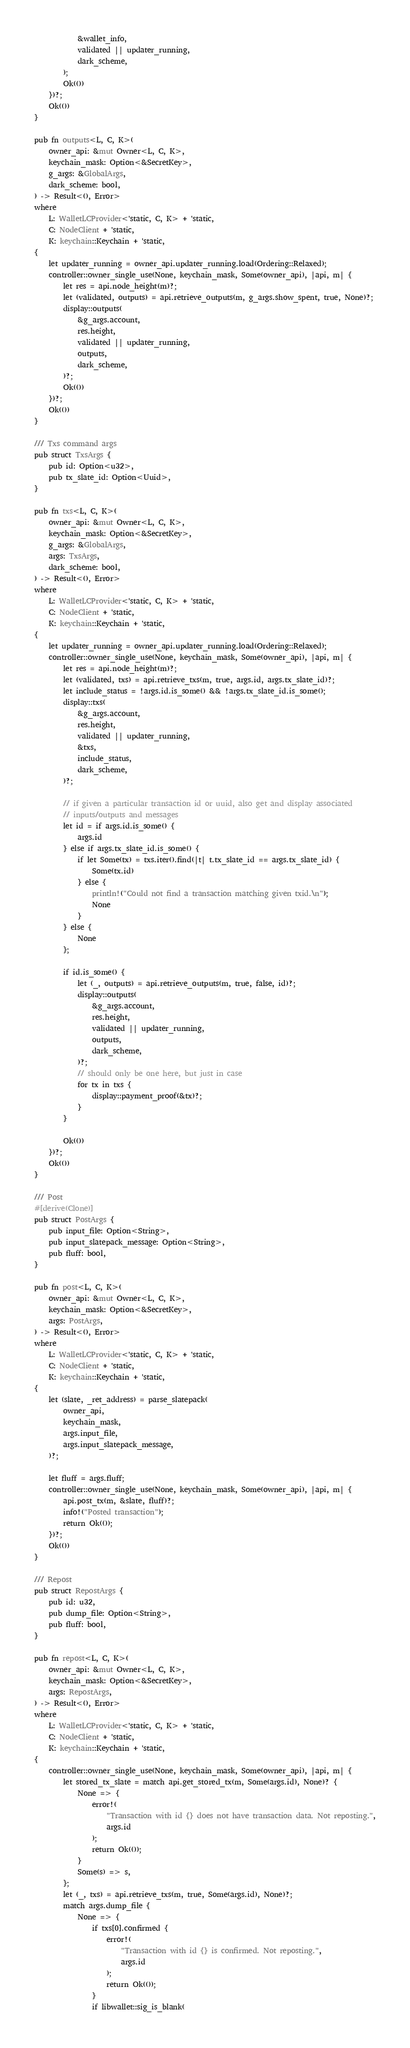Convert code to text. <code><loc_0><loc_0><loc_500><loc_500><_Rust_>			&wallet_info,
			validated || updater_running,
			dark_scheme,
		);
		Ok(())
	})?;
	Ok(())
}

pub fn outputs<L, C, K>(
	owner_api: &mut Owner<L, C, K>,
	keychain_mask: Option<&SecretKey>,
	g_args: &GlobalArgs,
	dark_scheme: bool,
) -> Result<(), Error>
where
	L: WalletLCProvider<'static, C, K> + 'static,
	C: NodeClient + 'static,
	K: keychain::Keychain + 'static,
{
	let updater_running = owner_api.updater_running.load(Ordering::Relaxed);
	controller::owner_single_use(None, keychain_mask, Some(owner_api), |api, m| {
		let res = api.node_height(m)?;
		let (validated, outputs) = api.retrieve_outputs(m, g_args.show_spent, true, None)?;
		display::outputs(
			&g_args.account,
			res.height,
			validated || updater_running,
			outputs,
			dark_scheme,
		)?;
		Ok(())
	})?;
	Ok(())
}

/// Txs command args
pub struct TxsArgs {
	pub id: Option<u32>,
	pub tx_slate_id: Option<Uuid>,
}

pub fn txs<L, C, K>(
	owner_api: &mut Owner<L, C, K>,
	keychain_mask: Option<&SecretKey>,
	g_args: &GlobalArgs,
	args: TxsArgs,
	dark_scheme: bool,
) -> Result<(), Error>
where
	L: WalletLCProvider<'static, C, K> + 'static,
	C: NodeClient + 'static,
	K: keychain::Keychain + 'static,
{
	let updater_running = owner_api.updater_running.load(Ordering::Relaxed);
	controller::owner_single_use(None, keychain_mask, Some(owner_api), |api, m| {
		let res = api.node_height(m)?;
		let (validated, txs) = api.retrieve_txs(m, true, args.id, args.tx_slate_id)?;
		let include_status = !args.id.is_some() && !args.tx_slate_id.is_some();
		display::txs(
			&g_args.account,
			res.height,
			validated || updater_running,
			&txs,
			include_status,
			dark_scheme,
		)?;

		// if given a particular transaction id or uuid, also get and display associated
		// inputs/outputs and messages
		let id = if args.id.is_some() {
			args.id
		} else if args.tx_slate_id.is_some() {
			if let Some(tx) = txs.iter().find(|t| t.tx_slate_id == args.tx_slate_id) {
				Some(tx.id)
			} else {
				println!("Could not find a transaction matching given txid.\n");
				None
			}
		} else {
			None
		};

		if id.is_some() {
			let (_, outputs) = api.retrieve_outputs(m, true, false, id)?;
			display::outputs(
				&g_args.account,
				res.height,
				validated || updater_running,
				outputs,
				dark_scheme,
			)?;
			// should only be one here, but just in case
			for tx in txs {
				display::payment_proof(&tx)?;
			}
		}

		Ok(())
	})?;
	Ok(())
}

/// Post
#[derive(Clone)]
pub struct PostArgs {
	pub input_file: Option<String>,
	pub input_slatepack_message: Option<String>,
	pub fluff: bool,
}

pub fn post<L, C, K>(
	owner_api: &mut Owner<L, C, K>,
	keychain_mask: Option<&SecretKey>,
	args: PostArgs,
) -> Result<(), Error>
where
	L: WalletLCProvider<'static, C, K> + 'static,
	C: NodeClient + 'static,
	K: keychain::Keychain + 'static,
{
	let (slate, _ret_address) = parse_slatepack(
		owner_api,
		keychain_mask,
		args.input_file,
		args.input_slatepack_message,
	)?;

	let fluff = args.fluff;
	controller::owner_single_use(None, keychain_mask, Some(owner_api), |api, m| {
		api.post_tx(m, &slate, fluff)?;
		info!("Posted transaction");
		return Ok(());
	})?;
	Ok(())
}

/// Repost
pub struct RepostArgs {
	pub id: u32,
	pub dump_file: Option<String>,
	pub fluff: bool,
}

pub fn repost<L, C, K>(
	owner_api: &mut Owner<L, C, K>,
	keychain_mask: Option<&SecretKey>,
	args: RepostArgs,
) -> Result<(), Error>
where
	L: WalletLCProvider<'static, C, K> + 'static,
	C: NodeClient + 'static,
	K: keychain::Keychain + 'static,
{
	controller::owner_single_use(None, keychain_mask, Some(owner_api), |api, m| {
		let stored_tx_slate = match api.get_stored_tx(m, Some(args.id), None)? {
			None => {
				error!(
					"Transaction with id {} does not have transaction data. Not reposting.",
					args.id
				);
				return Ok(());
			}
			Some(s) => s,
		};
		let (_, txs) = api.retrieve_txs(m, true, Some(args.id), None)?;
		match args.dump_file {
			None => {
				if txs[0].confirmed {
					error!(
						"Transaction with id {} is confirmed. Not reposting.",
						args.id
					);
					return Ok(());
				}
				if libwallet::sig_is_blank(</code> 